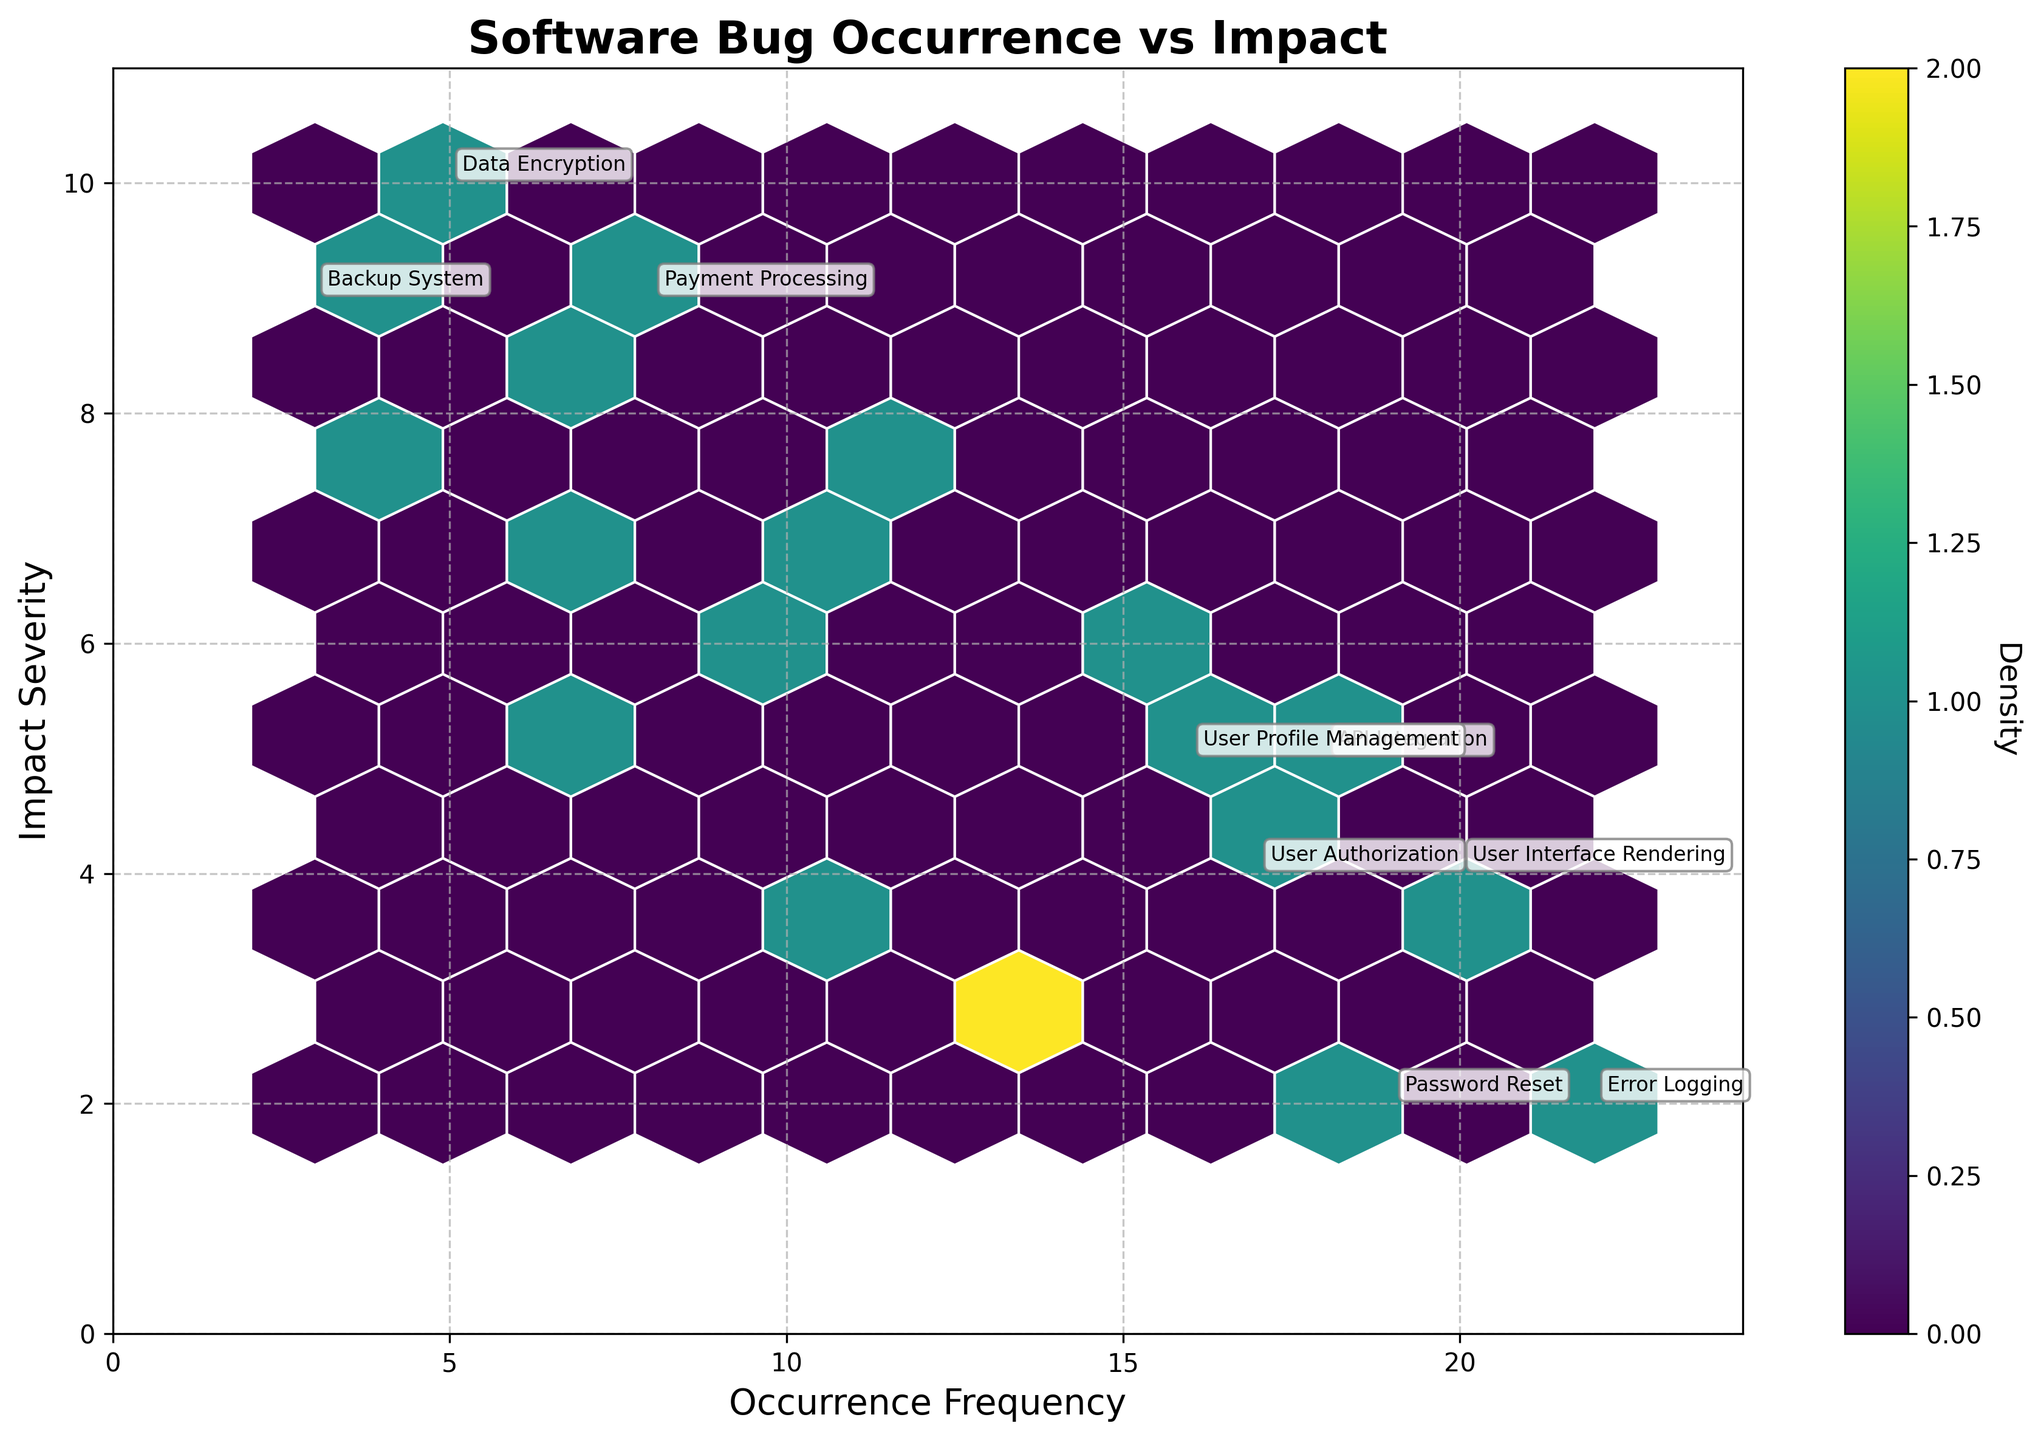Which module has the highest bug occurrence frequency? The module with the highest bug occurrence frequency is the one with the largest x-coordinate value. Looking at the plot, the "Error Logging" module has the highest occurrence frequency, which is 22.
Answer: Error Logging What is the title of the plot? The title of the plot is usually located at the top center of the figure. The title of this plot reads "Software Bug Occurrence vs Impact".
Answer: Software Bug Occurrence vs Impact What does the color intensity represent in the hexbin plot? In a hexbin plot, the color intensity represents the density of data points within each hexagonal bin. The color bar on the right side of the plot indicates that higher density areas are shown in more intense colors.
Answer: Density How many modules have an occurrence frequency greater than 15? To determine this, we look at the x-axis for occurrence frequencies greater than 15. The modules in these positions are "API Integration", "User Profile Management", "Payment Processing", and "Error Logging". Counting these, we get four modules.
Answer: 4 Which module has both high occurrence frequency and high impact severity? Modules with high occurrence frequency are those with high x-values, and with high impact severity, they have high y-values. The "User Authentication" module is annotated as one of the points satisfying both conditions.
Answer: User Authentication How is the grid size of the hexagons chosen for the plot? The grid size of hexagons is a parameter that can vary, here it is determined by the value set by the 'gridsize' parameter in the script. In this case, the plot uses a gridsize of 10, which means the plot space is divided into hexagons with dimensions fitting that grid.
Answer: 10 What is the range of impact severity in this plot? The impact severity is plotted along the y-axis. The maximum impact severity shown is slightly higher than 10, and the minimum is slightly below 2, making the range approximately from 2 to 10.
Answer: 2 to 10 How many modules have an impact severity of 9? Looking at the y-axis for y-value 9, the modules in this row are "Payment Processing" and "Backup System". Thus, there are two modules with an impact severity of 9.
Answer: 2 